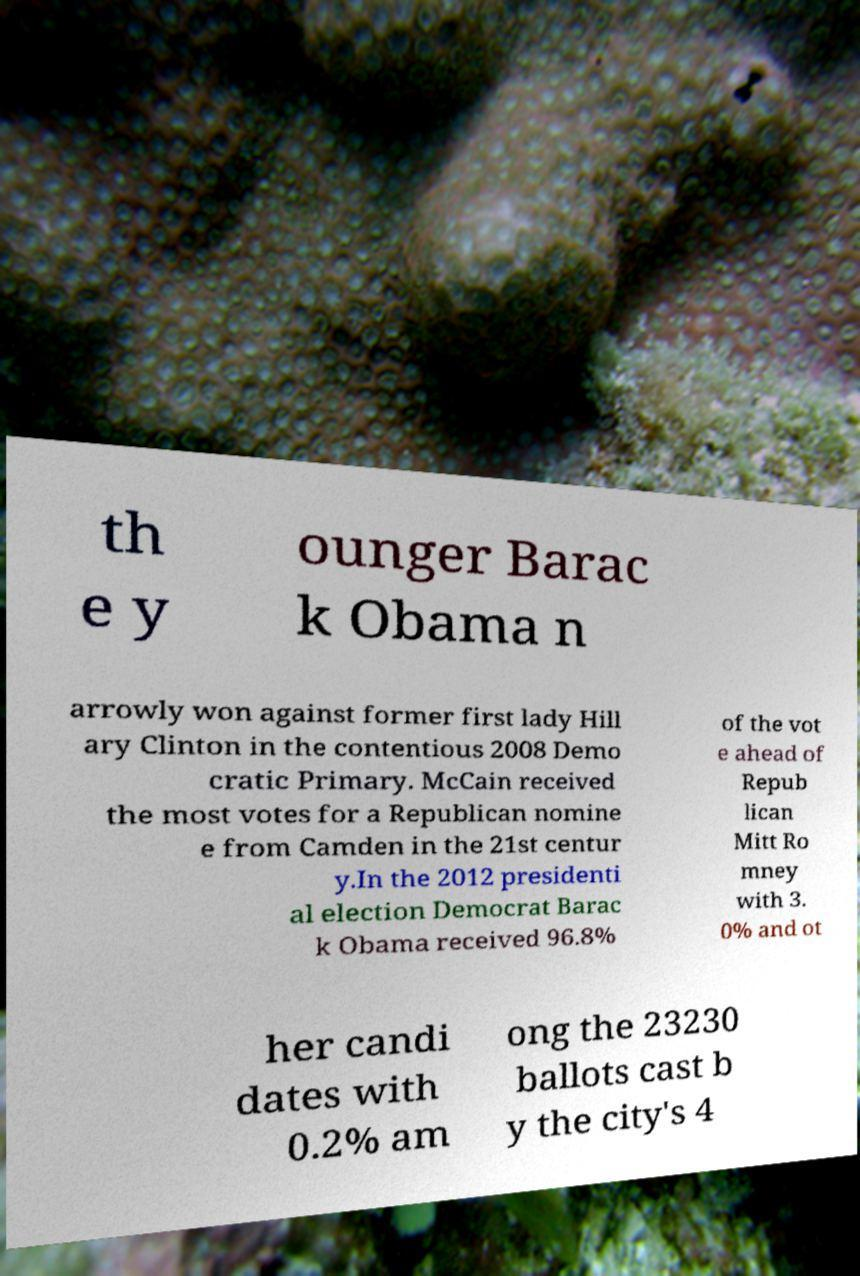Could you assist in decoding the text presented in this image and type it out clearly? th e y ounger Barac k Obama n arrowly won against former first lady Hill ary Clinton in the contentious 2008 Demo cratic Primary. McCain received the most votes for a Republican nomine e from Camden in the 21st centur y.In the 2012 presidenti al election Democrat Barac k Obama received 96.8% of the vot e ahead of Repub lican Mitt Ro mney with 3. 0% and ot her candi dates with 0.2% am ong the 23230 ballots cast b y the city's 4 